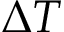Convert formula to latex. <formula><loc_0><loc_0><loc_500><loc_500>\Delta T</formula> 